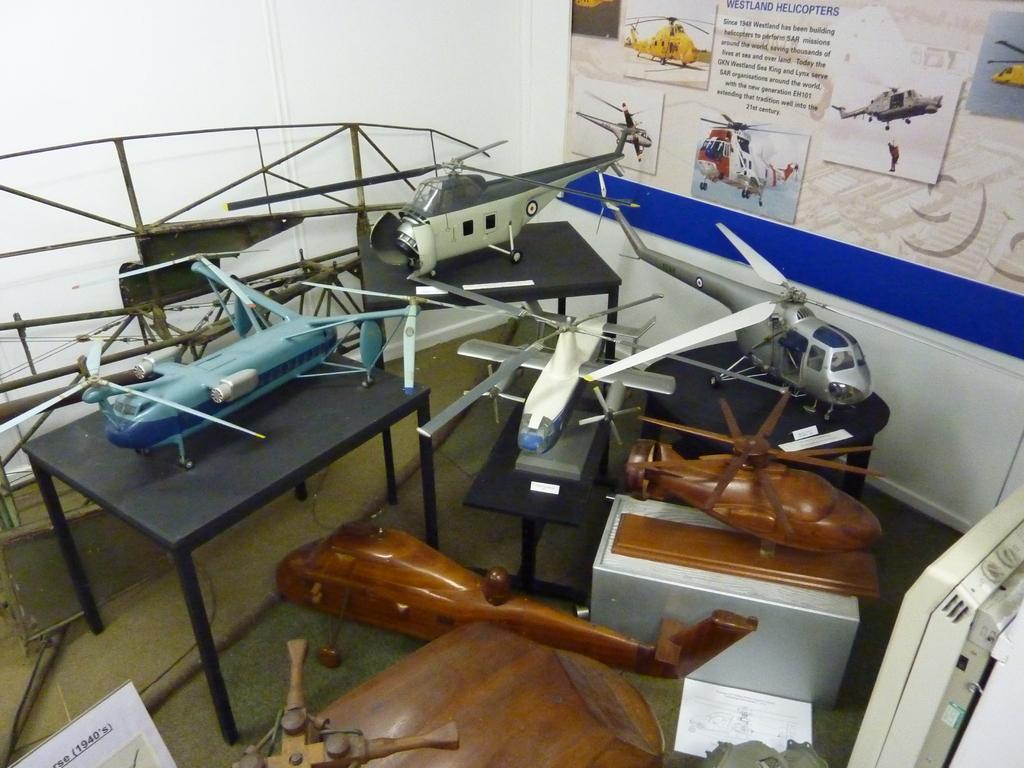In one or two sentences, can you explain what this image depicts? This picture shows the inner view of a room. There is one poster attached to the wall, some text and different aircraft pictures attached to the poster. There are four tables, some objects are on the table and so many objects are on the surface. 